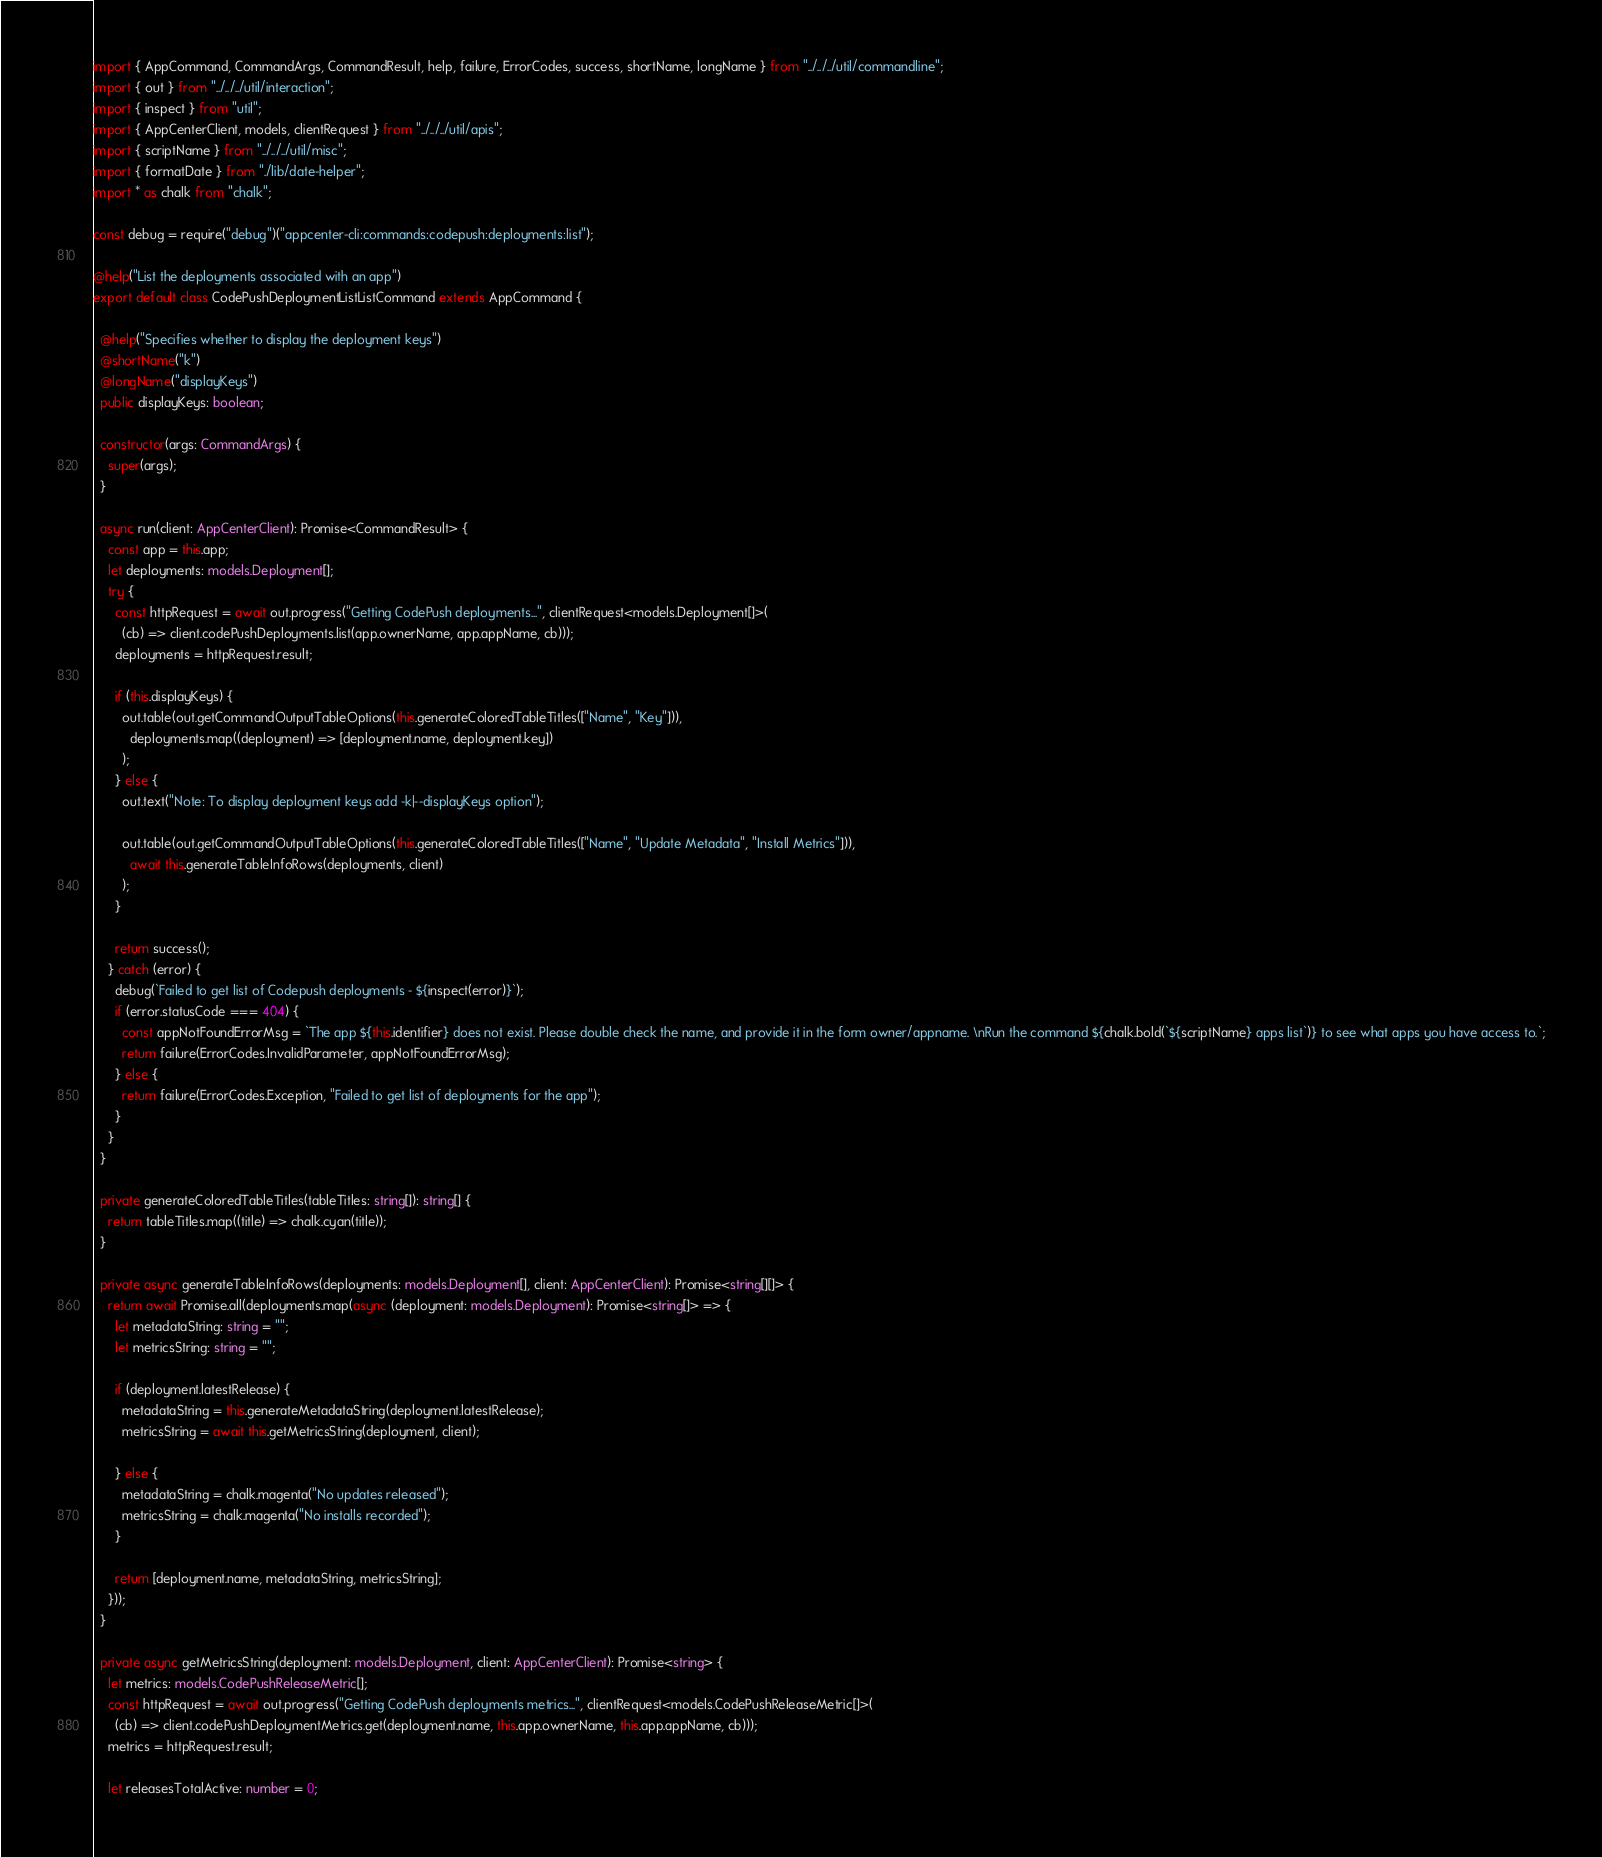<code> <loc_0><loc_0><loc_500><loc_500><_TypeScript_>import { AppCommand, CommandArgs, CommandResult, help, failure, ErrorCodes, success, shortName, longName } from "../../../util/commandline";
import { out } from "../../../util/interaction";
import { inspect } from "util";
import { AppCenterClient, models, clientRequest } from "../../../util/apis";
import { scriptName } from "../../../util/misc";
import { formatDate } from "./lib/date-helper";
import * as chalk from "chalk";

const debug = require("debug")("appcenter-cli:commands:codepush:deployments:list");

@help("List the deployments associated with an app")
export default class CodePushDeploymentListListCommand extends AppCommand {

  @help("Specifies whether to display the deployment keys")
  @shortName("k")
  @longName("displayKeys")
  public displayKeys: boolean;

  constructor(args: CommandArgs) {
    super(args);
  }

  async run(client: AppCenterClient): Promise<CommandResult> {
    const app = this.app;
    let deployments: models.Deployment[];
    try {
      const httpRequest = await out.progress("Getting CodePush deployments...", clientRequest<models.Deployment[]>(
        (cb) => client.codePushDeployments.list(app.ownerName, app.appName, cb)));
      deployments = httpRequest.result;

      if (this.displayKeys) {
        out.table(out.getCommandOutputTableOptions(this.generateColoredTableTitles(["Name", "Key"])),
          deployments.map((deployment) => [deployment.name, deployment.key])
        );
      } else {
        out.text("Note: To display deployment keys add -k|--displayKeys option");

        out.table(out.getCommandOutputTableOptions(this.generateColoredTableTitles(["Name", "Update Metadata", "Install Metrics"])),
          await this.generateTableInfoRows(deployments, client)
        );
      }

      return success();
    } catch (error) {
      debug(`Failed to get list of Codepush deployments - ${inspect(error)}`);
      if (error.statusCode === 404) {
        const appNotFoundErrorMsg = `The app ${this.identifier} does not exist. Please double check the name, and provide it in the form owner/appname. \nRun the command ${chalk.bold(`${scriptName} apps list`)} to see what apps you have access to.`;
        return failure(ErrorCodes.InvalidParameter, appNotFoundErrorMsg);
      } else {
        return failure(ErrorCodes.Exception, "Failed to get list of deployments for the app");
      }
    }
  }

  private generateColoredTableTitles(tableTitles: string[]): string[] {
    return tableTitles.map((title) => chalk.cyan(title));
  }

  private async generateTableInfoRows(deployments: models.Deployment[], client: AppCenterClient): Promise<string[][]> {
    return await Promise.all(deployments.map(async (deployment: models.Deployment): Promise<string[]> => {
      let metadataString: string = "";
      let metricsString: string = "";

      if (deployment.latestRelease) {
        metadataString = this.generateMetadataString(deployment.latestRelease);
        metricsString = await this.getMetricsString(deployment, client);

      } else {
        metadataString = chalk.magenta("No updates released");
        metricsString = chalk.magenta("No installs recorded");
      }

      return [deployment.name, metadataString, metricsString];
    }));
  }

  private async getMetricsString(deployment: models.Deployment, client: AppCenterClient): Promise<string> {
    let metrics: models.CodePushReleaseMetric[];
    const httpRequest = await out.progress("Getting CodePush deployments metrics...", clientRequest<models.CodePushReleaseMetric[]>(
      (cb) => client.codePushDeploymentMetrics.get(deployment.name, this.app.ownerName, this.app.appName, cb)));
    metrics = httpRequest.result;

    let releasesTotalActive: number = 0;</code> 